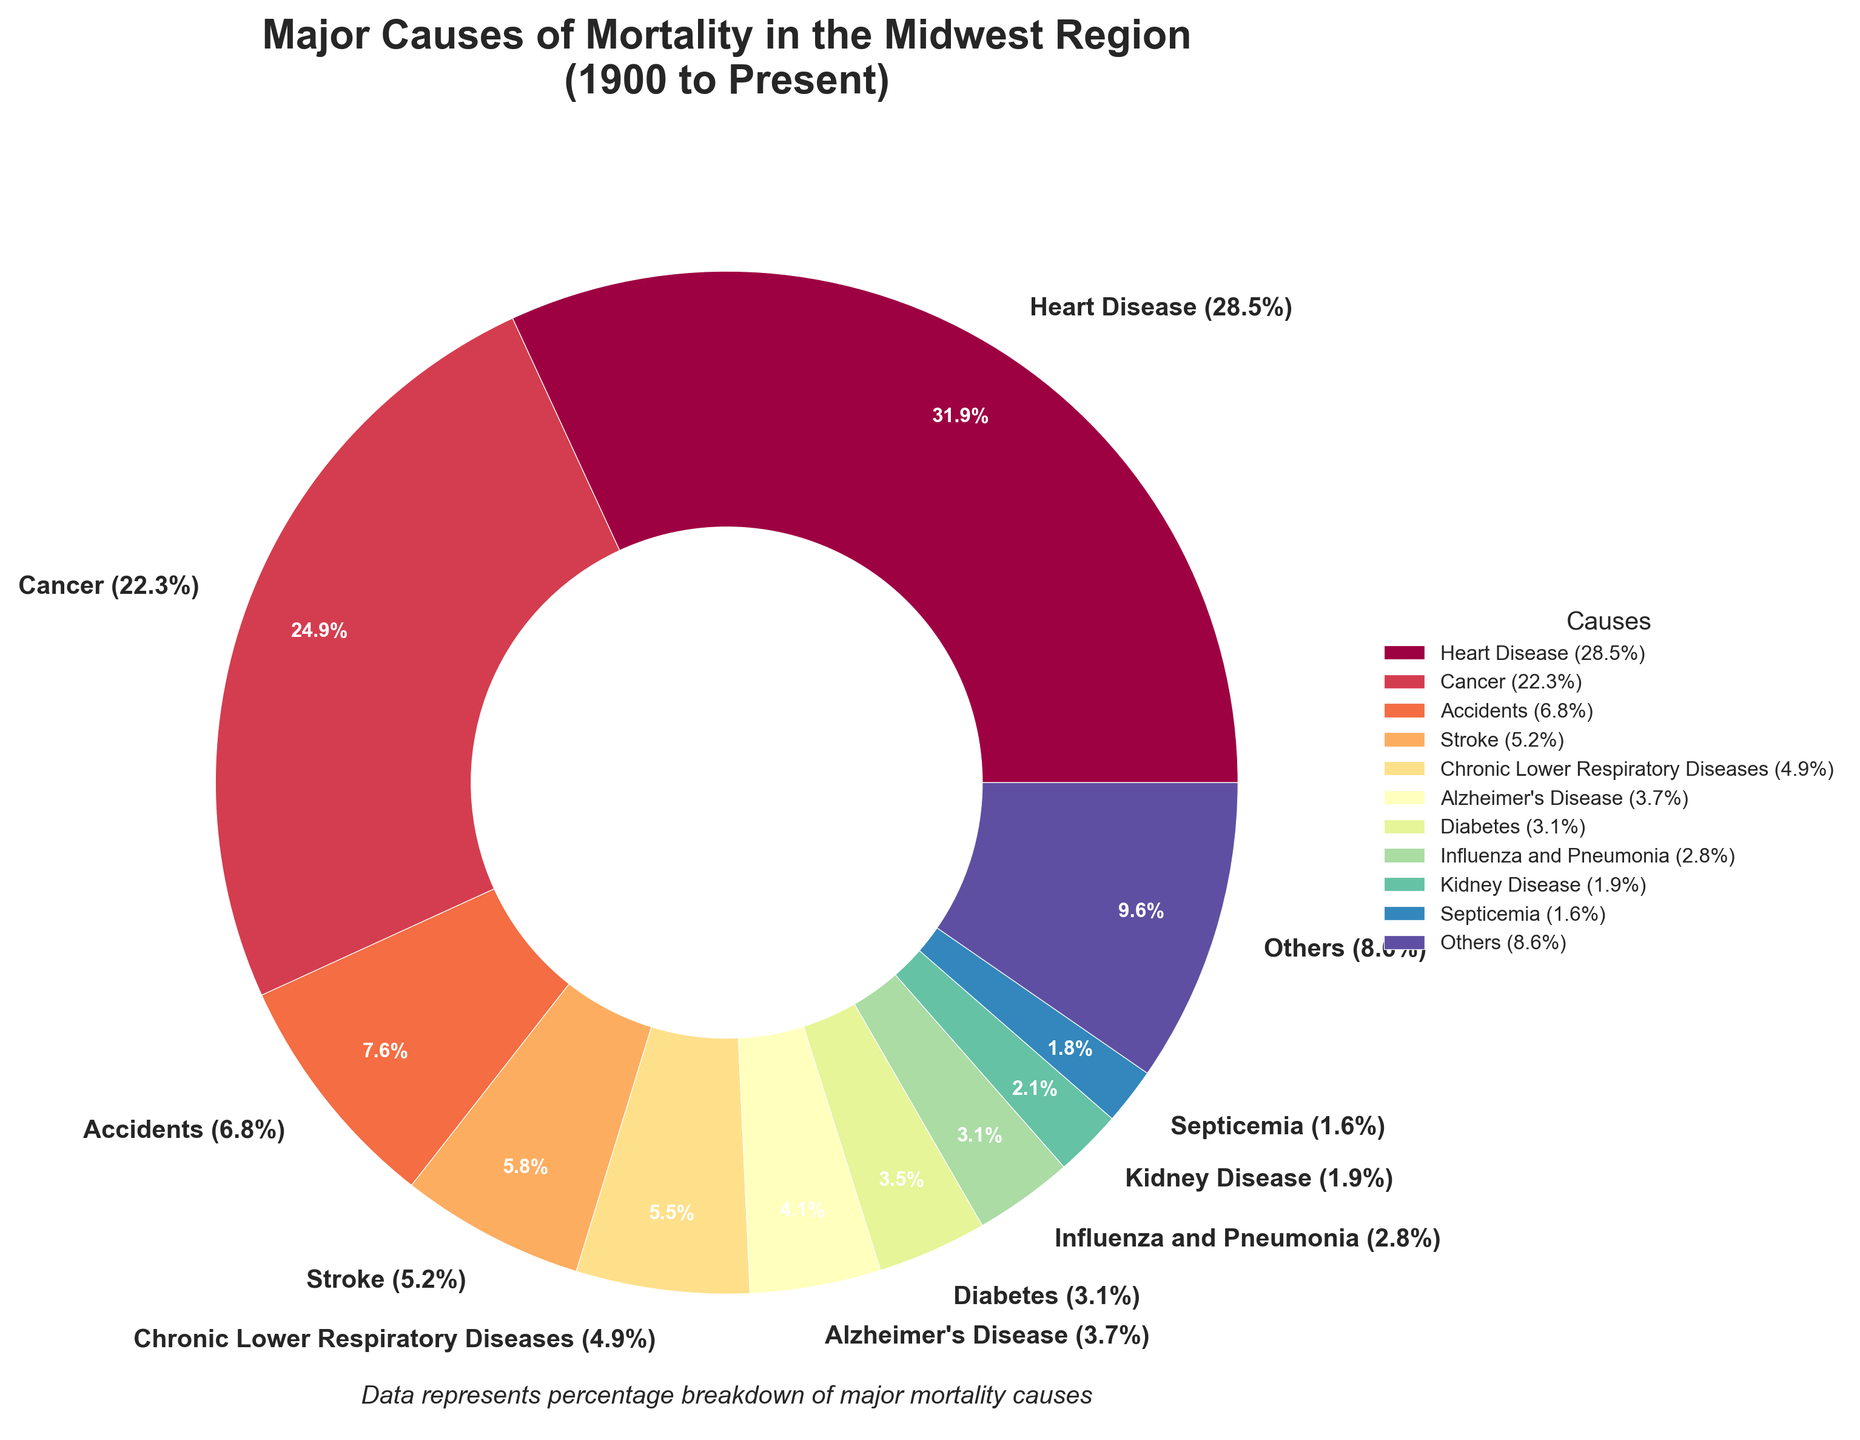Which cause has the highest percentage of mortality? The largest segment in the pie chart is Heart Disease, which is labeled with 28.5%.
Answer: Heart Disease What is the combined percentage of mortality for Cancer, Stroke, and Diabetes? The percentages for Cancer, Stroke, and Diabetes are 22.3%, 5.2%, and 3.1% respectively. Adding these together gives 22.3 + 5.2 + 3.1 = 30.6%.
Answer: 30.6% Is the percentage of deaths from Accidents greater or less than the percentage of deaths from Chronic Lower Respiratory Diseases? The pie chart shows Accidents with a percentage of 6.8% and Chronic Lower Respiratory Diseases with 4.9%. Since 6.8 is greater than 4.9, Accidents are greater.
Answer: Greater How much higher is the percentage of Heart Disease compared to Alzheimer’s Disease? Heart Disease is 28.5% and Alzheimer’s Disease is 3.7%. The difference is 28.5 - 3.7 = 24.8%.
Answer: 24.8% What percentage of the mortality does the 'Others' category represent? The pie chart groups lower percentages into the 'Others' category, and the label for 'Others' shows 14.7%.
Answer: 14.7% Which is larger, the percentage of deaths caused by Influenza and Pneumonia or the percentage of deaths caused by Kidney Disease? Influenza and Pneumonia are shown as 2.8% on the pie chart, and Kidney Disease has 1.9%. Since 2.8 is greater than 1.9, Influenza and Pneumonia is larger.
Answer: Influenza and Pneumonia Identify the visual color range pattern used for the pie segments. The colors transition from varying shades along a spectrum, which suggests a gradual change in color hues (probably from light to dark or vice versa).
Answer: Spectral color gradient Which two causes have the closest percentage of mortality? Chronic Lower Respiratory Diseases and Stroke have the closest percentages of 4.9% and 5.2% respectively, with a difference of 5.2 - 4.9 = 0.3%.
Answer: Stroke and Chronic Lower Respiratory Diseases How much bigger is the percentage of mortality from Cancer compared to Suicides? Cancer is 22.3% and Suicides is 1.4%. The difference is 22.3 - 1.4 = 20.9%.
Answer: 20.9% If Alzheimer's Disease and Pneumonitis due to solids and liquids had the same percentage, what would be the new total percentage for Alzheimer's Disease and Pneumonitis combined? Currently, Alzheimer's Disease is 3.7% and Pneumonitis is 0.9%. If they had the same percentage, it would be (3.7 + 3.7) = 7.4%. Adding these gives 7.4 + 0.9 = 8.3%.
Answer: 8.3% 